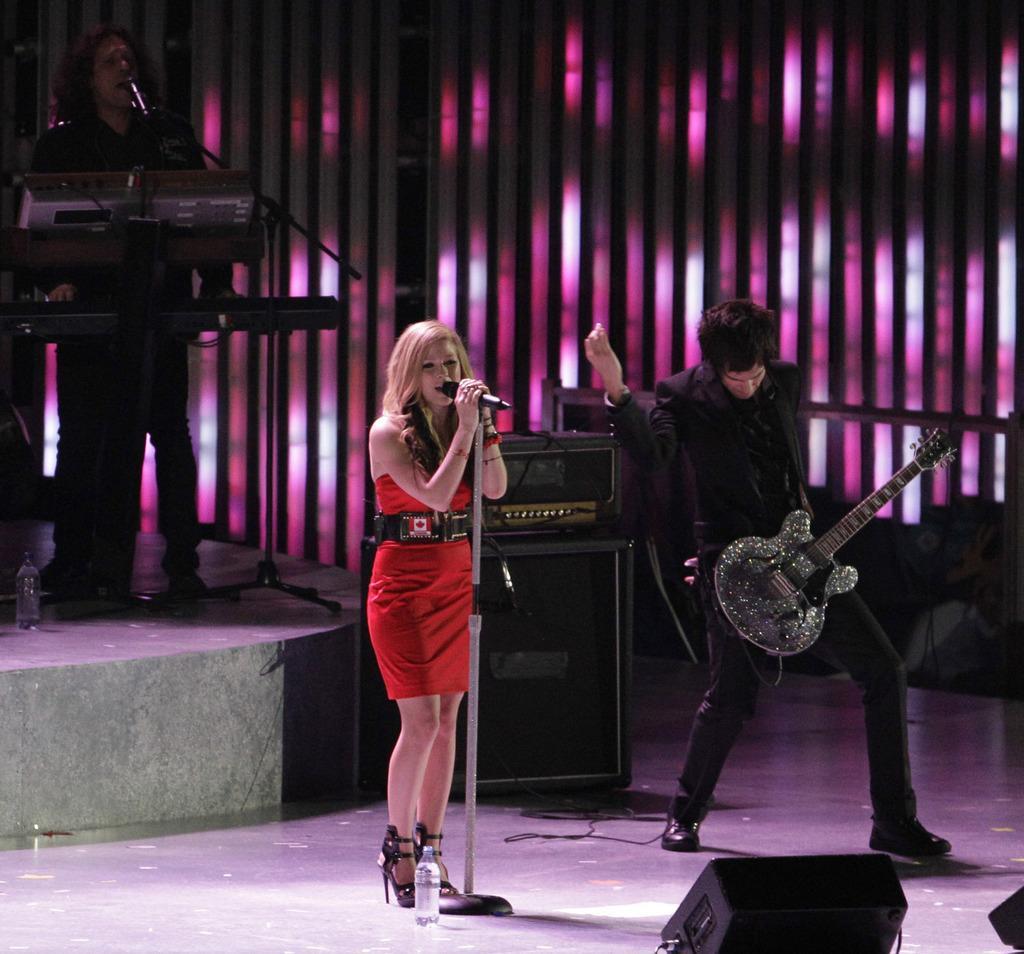Could you give a brief overview of what you see in this image? In this image we have a woman standing and singing a song in the microphone , and in the back ground we have another man standing and playing a guitar , speakers, another man standing and playing a piano and there is water bottle. 